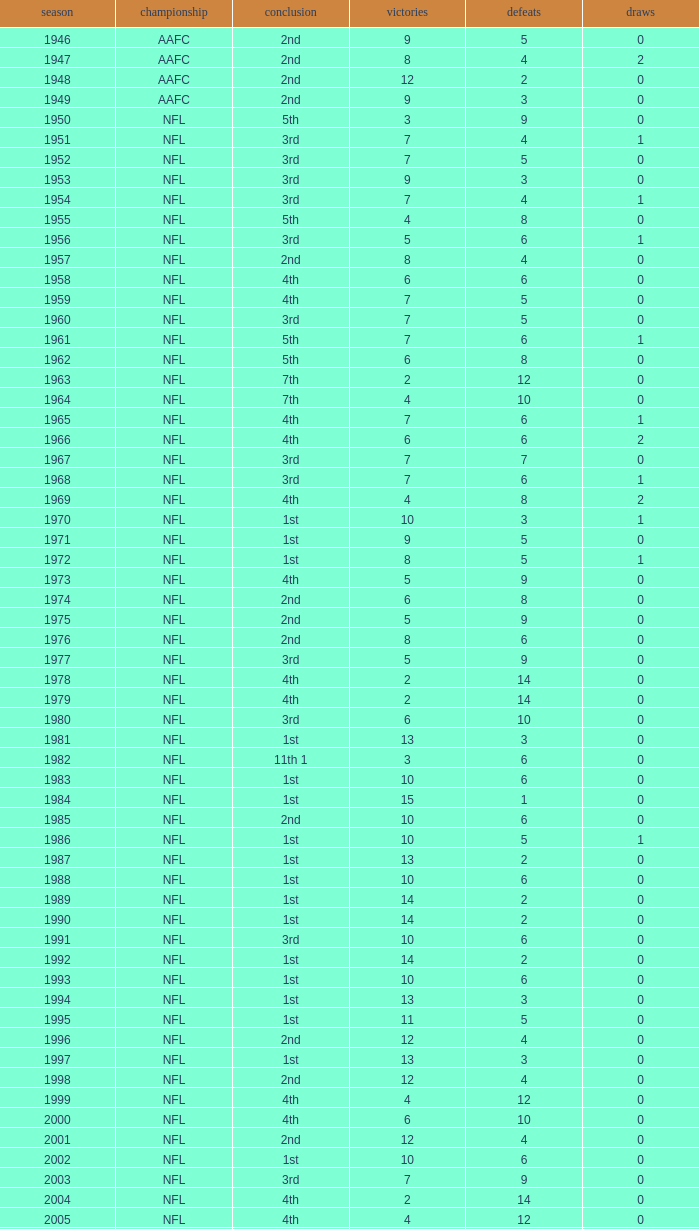What is the highest wins for the NFL with a finish of 1st, and more than 6 losses? None. 